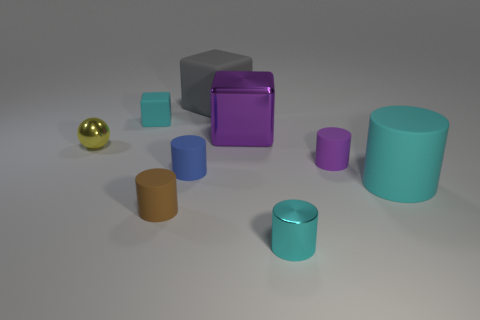What is the material of the tiny cylinder that is the same color as the tiny cube?
Make the answer very short. Metal. There is a cyan object that is to the left of the large metallic object; what size is it?
Your response must be concise. Small. Do the rubber block in front of the gray rubber thing and the small metallic cylinder have the same color?
Ensure brevity in your answer.  Yes. What number of large purple metallic things have the same shape as the small cyan rubber thing?
Offer a very short reply. 1. How many objects are either things that are left of the large matte cube or tiny matte objects behind the yellow metal sphere?
Your response must be concise. 4. What number of cyan objects are large rubber cylinders or shiny cubes?
Provide a short and direct response. 1. There is a cyan object that is both behind the tiny brown matte thing and on the right side of the gray thing; what material is it?
Your answer should be very brief. Rubber. Is the big cylinder made of the same material as the tiny yellow ball?
Your response must be concise. No. What number of blue shiny things have the same size as the shiny cylinder?
Offer a terse response. 0. Is the number of cylinders left of the cyan cube the same as the number of big gray metal cylinders?
Provide a succinct answer. Yes. 